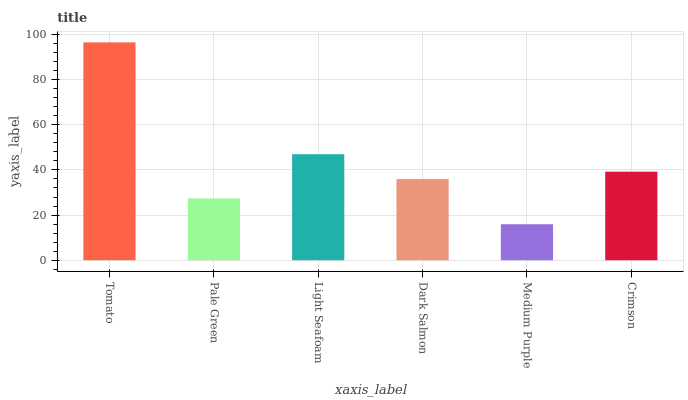Is Medium Purple the minimum?
Answer yes or no. Yes. Is Tomato the maximum?
Answer yes or no. Yes. Is Pale Green the minimum?
Answer yes or no. No. Is Pale Green the maximum?
Answer yes or no. No. Is Tomato greater than Pale Green?
Answer yes or no. Yes. Is Pale Green less than Tomato?
Answer yes or no. Yes. Is Pale Green greater than Tomato?
Answer yes or no. No. Is Tomato less than Pale Green?
Answer yes or no. No. Is Crimson the high median?
Answer yes or no. Yes. Is Dark Salmon the low median?
Answer yes or no. Yes. Is Pale Green the high median?
Answer yes or no. No. Is Crimson the low median?
Answer yes or no. No. 